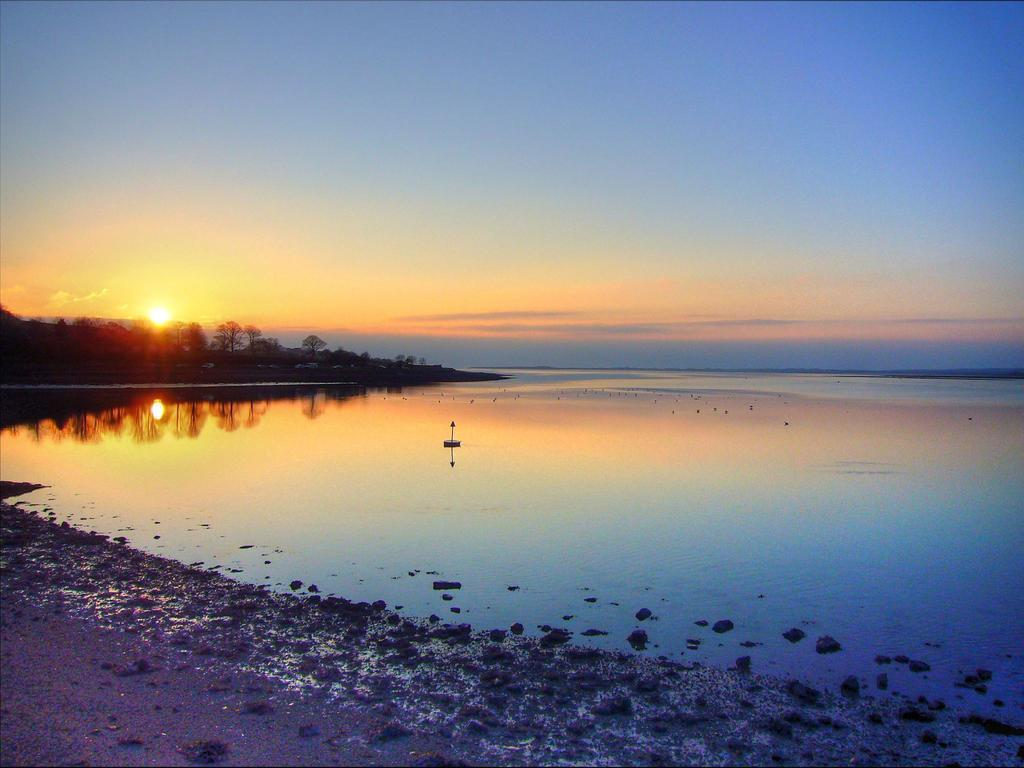What is the primary element present in the image? There is water in the image. What type of natural environment is depicted in the image? There is a seashore in the image. What can be seen in the background of the image? There is a group of trees and the sky visible in the background of the image. Can the sun be seen in the image? Yes, the sun is visible in the background of the image. How many sisters are present in the image? There are no people, let alone sisters, present in the image. The image primarily features water, a seashore, and natural background elements. 